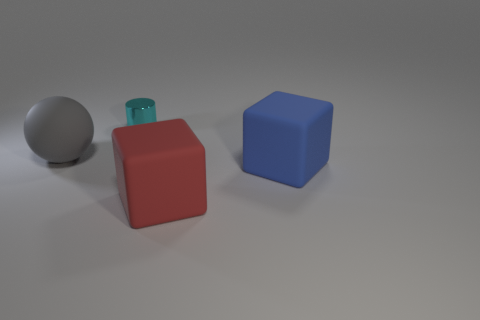Add 2 big gray rubber balls. How many objects exist? 6 Subtract all cylinders. How many objects are left? 3 Subtract all brown cylinders. Subtract all cyan cubes. How many cylinders are left? 1 Subtract all large blue cubes. Subtract all tiny yellow matte spheres. How many objects are left? 3 Add 2 large rubber balls. How many large rubber balls are left? 3 Add 2 purple metallic blocks. How many purple metallic blocks exist? 2 Subtract 1 gray balls. How many objects are left? 3 